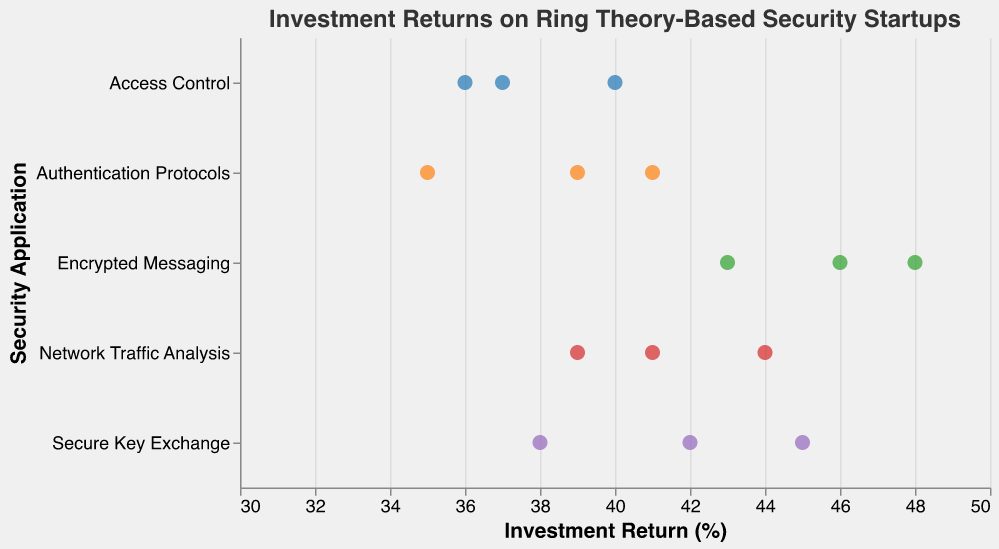What's the title of the plot? The title is at the top of the plot, and it reads "Investment Returns on Ring Theory-Based Security Startups."
Answer: Investment Returns on Ring Theory-Based Security Startups Which security application category has the highest maximum investment return? Looking at the x-axis values and comparing the highest points on the y-axis categories, Encrypted Messaging has a data point at 48%.
Answer: Encrypted Messaging What is the range of investment returns in Network Traffic Analysis? The x-axis values for Network Traffic Analysis range from 39% to 44%.
Answer: 39% to 44% How many security application categories are illustrated in the plot? By counting the unique y-axis labels, there are five categories: Secure Key Exchange, Authentication Protocols, Encrypted Messaging, Access Control, and Network Traffic Analysis.
Answer: Five Which startup in Secure Key Exchange has the lowest investment return? The lowest investment return in Secure Key Exchange is 38%, which corresponds to CyclicSafe.
Answer: CyclicSafe What's the average investment return for Authentication Protocols? The investment returns for Authentication Protocols are 35%, 39%, and 41%. Their average is (35 + 39 + 41) / 3 = 38.33%.
Answer: 38.33% Between Encrypted Messaging and Access Control, which category has a higher median investment return? Encrypted Messaging returns are 48%, 43%, and 46%. Access Control returns are 37%, 40%, 36%. Medians are 46% and 37% respectively. 46% > 37%.
Answer: Encrypted Messaging Which startup in the Network Traffic Analysis category has the highest investment return? The highest investment return in Network Traffic Analysis is 44%, which belongs to RingFlow.
Answer: RingFlow How does the investment return of RingCrypt compare with RingID? RingCrypt has an investment return of 42%, while RingID has 35%. 42% > 35%.
Answer: RingCrypt has a higher return than RingID What's the overall trend of the investment returns across different security applications? By observing the plot, the trend seems fairly consistent across categories, with some applications like Encrypted Messaging showing slightly higher returns overall.
Answer: Consistent trend, slightly higher for Encrypted Messaging 